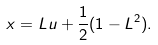<formula> <loc_0><loc_0><loc_500><loc_500>x = L u + \frac { 1 } { 2 } ( 1 - L ^ { 2 } ) .</formula> 